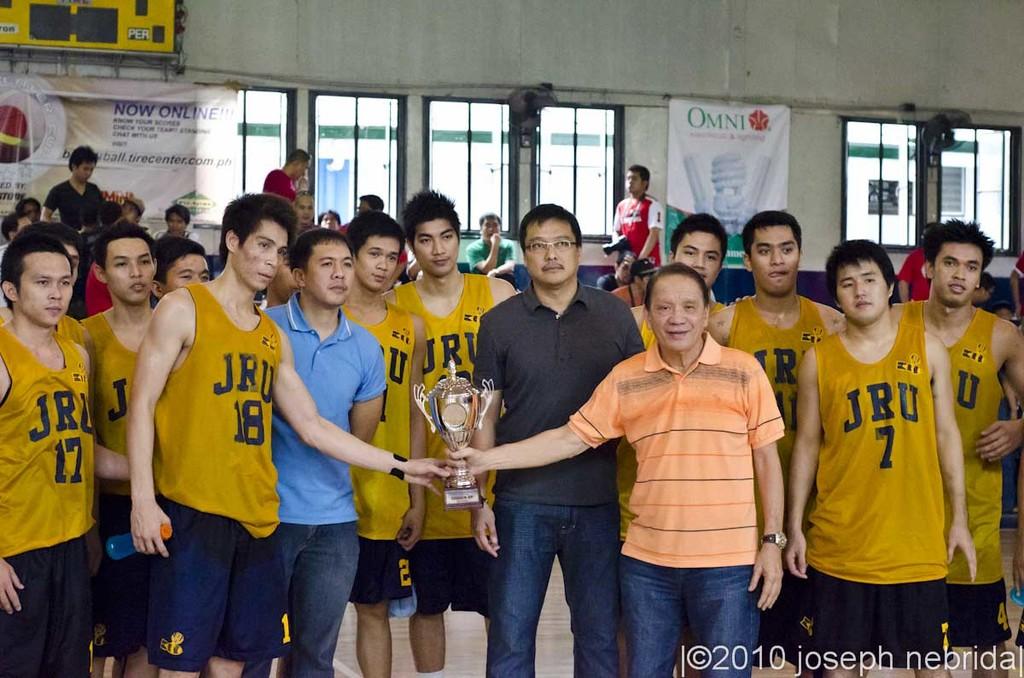What is the player's number on the right?
Provide a succinct answer. 7. 